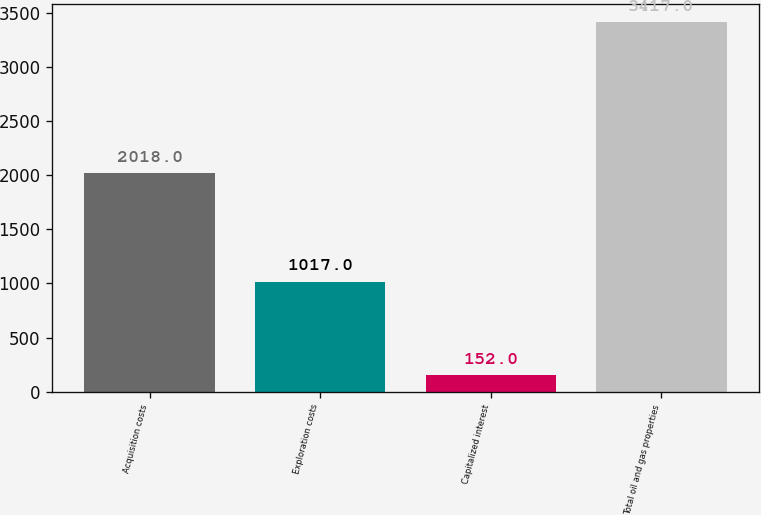Convert chart. <chart><loc_0><loc_0><loc_500><loc_500><bar_chart><fcel>Acquisition costs<fcel>Exploration costs<fcel>Capitalized interest<fcel>Total oil and gas properties<nl><fcel>2018<fcel>1017<fcel>152<fcel>3417<nl></chart> 